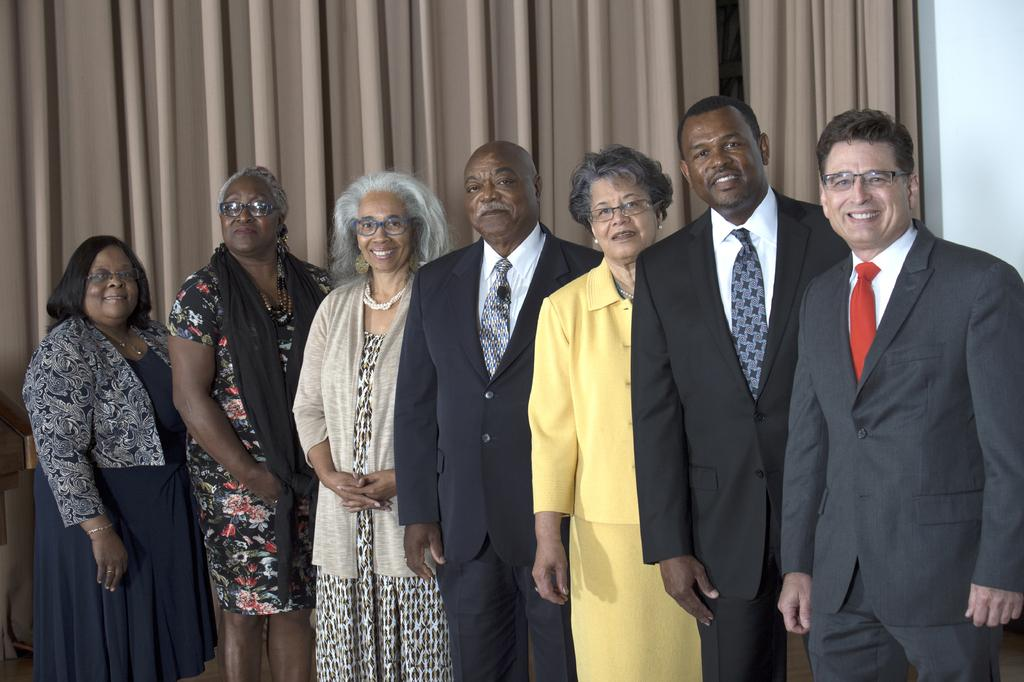What types of people are in the image? There are women and men in the image. What are the people doing in the image? The people are standing and smiling. What might be the purpose of their actions in the image? The people are posing for the picture. What can be seen on the wall in the background of the image? There is a curtain on the wall in the background of the image. What type of nail can be seen in the image? There is no nail present in the image. What day of the week is depicted in the image? The day of the week is not visible or mentioned in the image. 